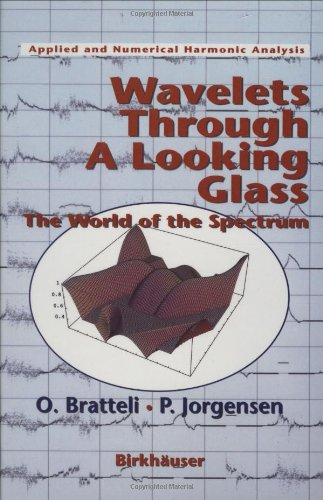What mathematical concepts are explored in this book related to wavelets? This book delves deeply into the theory of wavelets and their applications, particularly exploring how they relate to the spectrum in harmonic analysis. It emphasizes mathematical structures, Fourier analysis, and the transformation techniques pivotal in various fields of science and engineering. 